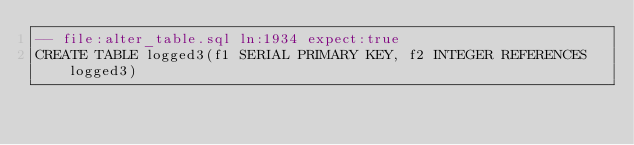<code> <loc_0><loc_0><loc_500><loc_500><_SQL_>-- file:alter_table.sql ln:1934 expect:true
CREATE TABLE logged3(f1 SERIAL PRIMARY KEY, f2 INTEGER REFERENCES logged3)
</code> 